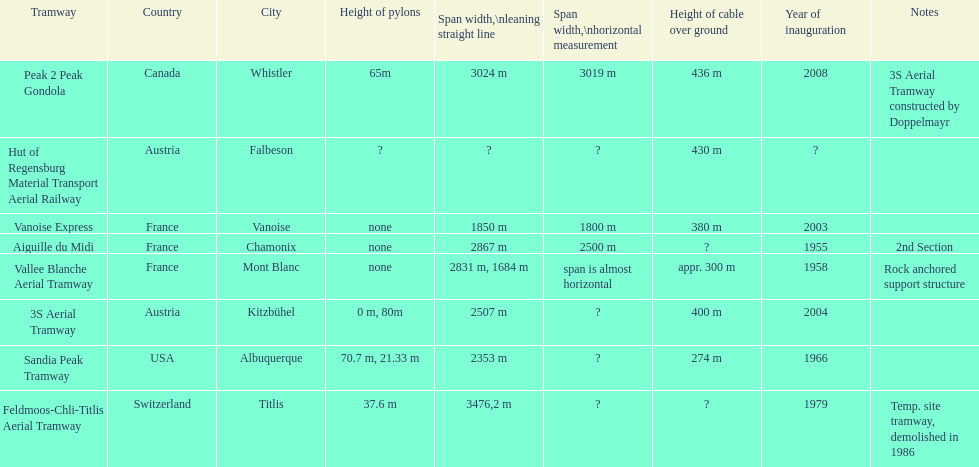What is the additional length of the peak 2 peak gondola compared to the 32 aerial tramway? 517. Parse the table in full. {'header': ['Tramway', 'Country', 'City', 'Height of pylons', 'Span\xa0width,\\nleaning straight line', 'Span width,\\nhorizontal measurement', 'Height of cable over ground', 'Year of inauguration', 'Notes'], 'rows': [['Peak 2 Peak Gondola', 'Canada', 'Whistler', '65m', '3024 m', '3019 m', '436 m', '2008', '3S Aerial Tramway constructed by Doppelmayr'], ['Hut of Regensburg Material Transport Aerial Railway', 'Austria', 'Falbeson', '?', '?', '?', '430 m', '?', ''], ['Vanoise Express', 'France', 'Vanoise', 'none', '1850 m', '1800 m', '380 m', '2003', ''], ['Aiguille du Midi', 'France', 'Chamonix', 'none', '2867 m', '2500 m', '?', '1955', '2nd Section'], ['Vallee Blanche Aerial Tramway', 'France', 'Mont Blanc', 'none', '2831 m, 1684 m', 'span is almost horizontal', 'appr. 300 m', '1958', 'Rock anchored support structure'], ['3S Aerial Tramway', 'Austria', 'Kitzbühel', '0 m, 80m', '2507 m', '?', '400 m', '2004', ''], ['Sandia Peak Tramway', 'USA', 'Albuquerque', '70.7 m, 21.33 m', '2353 m', '?', '274 m', '1966', ''], ['Feldmoos-Chli-Titlis Aerial Tramway', 'Switzerland', 'Titlis', '37.6 m', '3476,2 m', '?', '?', '1979', 'Temp. site tramway, demolished in 1986']]} 